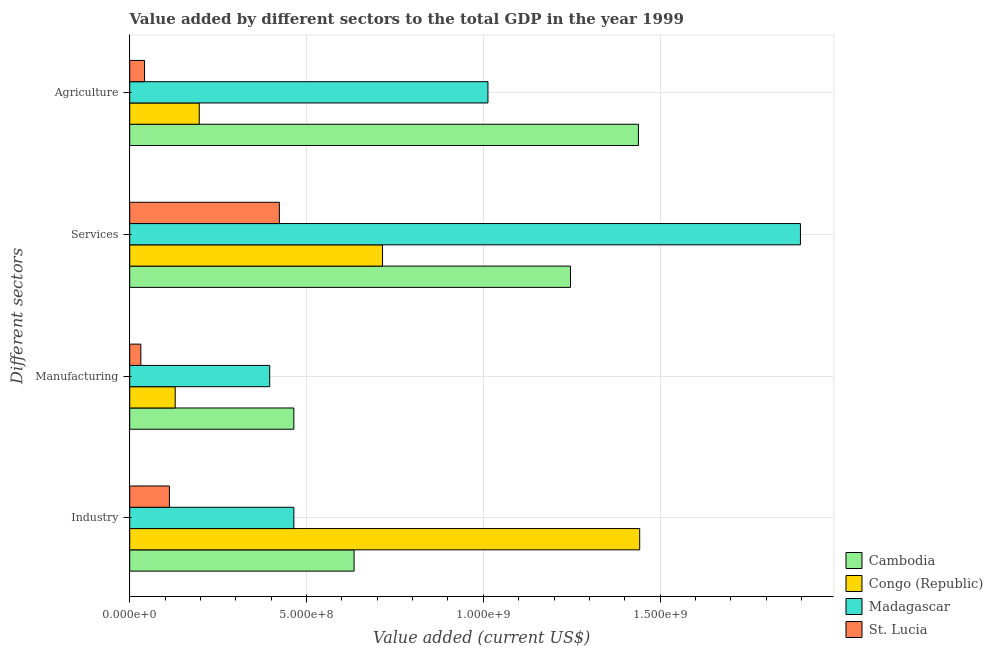How many bars are there on the 1st tick from the top?
Give a very brief answer. 4. How many bars are there on the 3rd tick from the bottom?
Provide a succinct answer. 4. What is the label of the 3rd group of bars from the top?
Provide a short and direct response. Manufacturing. What is the value added by manufacturing sector in Madagascar?
Ensure brevity in your answer.  3.96e+08. Across all countries, what is the maximum value added by industrial sector?
Offer a terse response. 1.44e+09. Across all countries, what is the minimum value added by services sector?
Keep it short and to the point. 4.23e+08. In which country was the value added by services sector maximum?
Provide a short and direct response. Madagascar. In which country was the value added by agricultural sector minimum?
Your answer should be very brief. St. Lucia. What is the total value added by manufacturing sector in the graph?
Provide a succinct answer. 1.02e+09. What is the difference between the value added by agricultural sector in Madagascar and that in St. Lucia?
Offer a terse response. 9.71e+08. What is the difference between the value added by industrial sector in St. Lucia and the value added by agricultural sector in Cambodia?
Your answer should be very brief. -1.33e+09. What is the average value added by services sector per country?
Provide a succinct answer. 1.07e+09. What is the difference between the value added by services sector and value added by manufacturing sector in Madagascar?
Ensure brevity in your answer.  1.50e+09. What is the ratio of the value added by agricultural sector in Cambodia to that in Congo (Republic)?
Offer a terse response. 7.31. Is the value added by services sector in Congo (Republic) less than that in Madagascar?
Your answer should be very brief. Yes. Is the difference between the value added by manufacturing sector in Congo (Republic) and Cambodia greater than the difference between the value added by services sector in Congo (Republic) and Cambodia?
Ensure brevity in your answer.  Yes. What is the difference between the highest and the second highest value added by agricultural sector?
Provide a succinct answer. 4.26e+08. What is the difference between the highest and the lowest value added by manufacturing sector?
Provide a succinct answer. 4.33e+08. In how many countries, is the value added by industrial sector greater than the average value added by industrial sector taken over all countries?
Make the answer very short. 1. What does the 4th bar from the top in Industry represents?
Your answer should be compact. Cambodia. What does the 1st bar from the bottom in Industry represents?
Offer a terse response. Cambodia. How many bars are there?
Your answer should be compact. 16. Are all the bars in the graph horizontal?
Your answer should be compact. Yes. Are the values on the major ticks of X-axis written in scientific E-notation?
Keep it short and to the point. Yes. Does the graph contain grids?
Your answer should be compact. Yes. How many legend labels are there?
Keep it short and to the point. 4. What is the title of the graph?
Make the answer very short. Value added by different sectors to the total GDP in the year 1999. What is the label or title of the X-axis?
Offer a terse response. Value added (current US$). What is the label or title of the Y-axis?
Keep it short and to the point. Different sectors. What is the Value added (current US$) in Cambodia in Industry?
Keep it short and to the point. 6.35e+08. What is the Value added (current US$) of Congo (Republic) in Industry?
Provide a succinct answer. 1.44e+09. What is the Value added (current US$) of Madagascar in Industry?
Ensure brevity in your answer.  4.64e+08. What is the Value added (current US$) in St. Lucia in Industry?
Your response must be concise. 1.12e+08. What is the Value added (current US$) in Cambodia in Manufacturing?
Provide a short and direct response. 4.64e+08. What is the Value added (current US$) in Congo (Republic) in Manufacturing?
Your response must be concise. 1.29e+08. What is the Value added (current US$) in Madagascar in Manufacturing?
Your answer should be very brief. 3.96e+08. What is the Value added (current US$) of St. Lucia in Manufacturing?
Your answer should be compact. 3.14e+07. What is the Value added (current US$) of Cambodia in Services?
Keep it short and to the point. 1.25e+09. What is the Value added (current US$) of Congo (Republic) in Services?
Provide a short and direct response. 7.15e+08. What is the Value added (current US$) of Madagascar in Services?
Offer a terse response. 1.90e+09. What is the Value added (current US$) in St. Lucia in Services?
Give a very brief answer. 4.23e+08. What is the Value added (current US$) of Cambodia in Agriculture?
Offer a very short reply. 1.44e+09. What is the Value added (current US$) of Congo (Republic) in Agriculture?
Your answer should be compact. 1.97e+08. What is the Value added (current US$) of Madagascar in Agriculture?
Offer a terse response. 1.01e+09. What is the Value added (current US$) of St. Lucia in Agriculture?
Your answer should be very brief. 4.19e+07. Across all Different sectors, what is the maximum Value added (current US$) of Cambodia?
Make the answer very short. 1.44e+09. Across all Different sectors, what is the maximum Value added (current US$) of Congo (Republic)?
Offer a very short reply. 1.44e+09. Across all Different sectors, what is the maximum Value added (current US$) of Madagascar?
Offer a very short reply. 1.90e+09. Across all Different sectors, what is the maximum Value added (current US$) of St. Lucia?
Your response must be concise. 4.23e+08. Across all Different sectors, what is the minimum Value added (current US$) of Cambodia?
Provide a succinct answer. 4.64e+08. Across all Different sectors, what is the minimum Value added (current US$) in Congo (Republic)?
Give a very brief answer. 1.29e+08. Across all Different sectors, what is the minimum Value added (current US$) in Madagascar?
Give a very brief answer. 3.96e+08. Across all Different sectors, what is the minimum Value added (current US$) of St. Lucia?
Make the answer very short. 3.14e+07. What is the total Value added (current US$) of Cambodia in the graph?
Your answer should be very brief. 3.78e+09. What is the total Value added (current US$) of Congo (Republic) in the graph?
Provide a succinct answer. 2.48e+09. What is the total Value added (current US$) of Madagascar in the graph?
Your response must be concise. 3.77e+09. What is the total Value added (current US$) in St. Lucia in the graph?
Make the answer very short. 6.09e+08. What is the difference between the Value added (current US$) in Cambodia in Industry and that in Manufacturing?
Offer a very short reply. 1.70e+08. What is the difference between the Value added (current US$) of Congo (Republic) in Industry and that in Manufacturing?
Your response must be concise. 1.31e+09. What is the difference between the Value added (current US$) in Madagascar in Industry and that in Manufacturing?
Ensure brevity in your answer.  6.83e+07. What is the difference between the Value added (current US$) in St. Lucia in Industry and that in Manufacturing?
Offer a very short reply. 8.08e+07. What is the difference between the Value added (current US$) in Cambodia in Industry and that in Services?
Offer a terse response. -6.12e+08. What is the difference between the Value added (current US$) in Congo (Republic) in Industry and that in Services?
Offer a terse response. 7.27e+08. What is the difference between the Value added (current US$) in Madagascar in Industry and that in Services?
Provide a succinct answer. -1.43e+09. What is the difference between the Value added (current US$) in St. Lucia in Industry and that in Services?
Provide a short and direct response. -3.11e+08. What is the difference between the Value added (current US$) in Cambodia in Industry and that in Agriculture?
Provide a short and direct response. -8.04e+08. What is the difference between the Value added (current US$) in Congo (Republic) in Industry and that in Agriculture?
Make the answer very short. 1.25e+09. What is the difference between the Value added (current US$) of Madagascar in Industry and that in Agriculture?
Your answer should be compact. -5.49e+08. What is the difference between the Value added (current US$) in St. Lucia in Industry and that in Agriculture?
Your response must be concise. 7.03e+07. What is the difference between the Value added (current US$) in Cambodia in Manufacturing and that in Services?
Your answer should be compact. -7.82e+08. What is the difference between the Value added (current US$) in Congo (Republic) in Manufacturing and that in Services?
Give a very brief answer. -5.86e+08. What is the difference between the Value added (current US$) in Madagascar in Manufacturing and that in Services?
Make the answer very short. -1.50e+09. What is the difference between the Value added (current US$) of St. Lucia in Manufacturing and that in Services?
Ensure brevity in your answer.  -3.92e+08. What is the difference between the Value added (current US$) of Cambodia in Manufacturing and that in Agriculture?
Provide a succinct answer. -9.75e+08. What is the difference between the Value added (current US$) in Congo (Republic) in Manufacturing and that in Agriculture?
Your answer should be very brief. -6.81e+07. What is the difference between the Value added (current US$) of Madagascar in Manufacturing and that in Agriculture?
Make the answer very short. -6.17e+08. What is the difference between the Value added (current US$) of St. Lucia in Manufacturing and that in Agriculture?
Your answer should be very brief. -1.05e+07. What is the difference between the Value added (current US$) in Cambodia in Services and that in Agriculture?
Your answer should be very brief. -1.92e+08. What is the difference between the Value added (current US$) of Congo (Republic) in Services and that in Agriculture?
Offer a terse response. 5.18e+08. What is the difference between the Value added (current US$) in Madagascar in Services and that in Agriculture?
Offer a very short reply. 8.84e+08. What is the difference between the Value added (current US$) of St. Lucia in Services and that in Agriculture?
Ensure brevity in your answer.  3.81e+08. What is the difference between the Value added (current US$) of Cambodia in Industry and the Value added (current US$) of Congo (Republic) in Manufacturing?
Provide a short and direct response. 5.06e+08. What is the difference between the Value added (current US$) in Cambodia in Industry and the Value added (current US$) in Madagascar in Manufacturing?
Offer a very short reply. 2.39e+08. What is the difference between the Value added (current US$) in Cambodia in Industry and the Value added (current US$) in St. Lucia in Manufacturing?
Ensure brevity in your answer.  6.03e+08. What is the difference between the Value added (current US$) in Congo (Republic) in Industry and the Value added (current US$) in Madagascar in Manufacturing?
Your answer should be compact. 1.05e+09. What is the difference between the Value added (current US$) of Congo (Republic) in Industry and the Value added (current US$) of St. Lucia in Manufacturing?
Your answer should be very brief. 1.41e+09. What is the difference between the Value added (current US$) in Madagascar in Industry and the Value added (current US$) in St. Lucia in Manufacturing?
Your answer should be compact. 4.33e+08. What is the difference between the Value added (current US$) in Cambodia in Industry and the Value added (current US$) in Congo (Republic) in Services?
Your response must be concise. -8.05e+07. What is the difference between the Value added (current US$) in Cambodia in Industry and the Value added (current US$) in Madagascar in Services?
Provide a succinct answer. -1.26e+09. What is the difference between the Value added (current US$) of Cambodia in Industry and the Value added (current US$) of St. Lucia in Services?
Make the answer very short. 2.11e+08. What is the difference between the Value added (current US$) of Congo (Republic) in Industry and the Value added (current US$) of Madagascar in Services?
Ensure brevity in your answer.  -4.55e+08. What is the difference between the Value added (current US$) of Congo (Republic) in Industry and the Value added (current US$) of St. Lucia in Services?
Offer a terse response. 1.02e+09. What is the difference between the Value added (current US$) in Madagascar in Industry and the Value added (current US$) in St. Lucia in Services?
Your answer should be very brief. 4.10e+07. What is the difference between the Value added (current US$) of Cambodia in Industry and the Value added (current US$) of Congo (Republic) in Agriculture?
Your answer should be compact. 4.38e+08. What is the difference between the Value added (current US$) of Cambodia in Industry and the Value added (current US$) of Madagascar in Agriculture?
Give a very brief answer. -3.79e+08. What is the difference between the Value added (current US$) in Cambodia in Industry and the Value added (current US$) in St. Lucia in Agriculture?
Your response must be concise. 5.93e+08. What is the difference between the Value added (current US$) in Congo (Republic) in Industry and the Value added (current US$) in Madagascar in Agriculture?
Keep it short and to the point. 4.29e+08. What is the difference between the Value added (current US$) in Congo (Republic) in Industry and the Value added (current US$) in St. Lucia in Agriculture?
Provide a short and direct response. 1.40e+09. What is the difference between the Value added (current US$) in Madagascar in Industry and the Value added (current US$) in St. Lucia in Agriculture?
Keep it short and to the point. 4.22e+08. What is the difference between the Value added (current US$) in Cambodia in Manufacturing and the Value added (current US$) in Congo (Republic) in Services?
Ensure brevity in your answer.  -2.51e+08. What is the difference between the Value added (current US$) in Cambodia in Manufacturing and the Value added (current US$) in Madagascar in Services?
Your answer should be compact. -1.43e+09. What is the difference between the Value added (current US$) in Cambodia in Manufacturing and the Value added (current US$) in St. Lucia in Services?
Offer a very short reply. 4.10e+07. What is the difference between the Value added (current US$) of Congo (Republic) in Manufacturing and the Value added (current US$) of Madagascar in Services?
Your answer should be very brief. -1.77e+09. What is the difference between the Value added (current US$) in Congo (Republic) in Manufacturing and the Value added (current US$) in St. Lucia in Services?
Provide a short and direct response. -2.95e+08. What is the difference between the Value added (current US$) of Madagascar in Manufacturing and the Value added (current US$) of St. Lucia in Services?
Your answer should be very brief. -2.73e+07. What is the difference between the Value added (current US$) in Cambodia in Manufacturing and the Value added (current US$) in Congo (Republic) in Agriculture?
Make the answer very short. 2.67e+08. What is the difference between the Value added (current US$) in Cambodia in Manufacturing and the Value added (current US$) in Madagascar in Agriculture?
Provide a short and direct response. -5.49e+08. What is the difference between the Value added (current US$) in Cambodia in Manufacturing and the Value added (current US$) in St. Lucia in Agriculture?
Give a very brief answer. 4.22e+08. What is the difference between the Value added (current US$) of Congo (Republic) in Manufacturing and the Value added (current US$) of Madagascar in Agriculture?
Your response must be concise. -8.84e+08. What is the difference between the Value added (current US$) of Congo (Republic) in Manufacturing and the Value added (current US$) of St. Lucia in Agriculture?
Your answer should be compact. 8.67e+07. What is the difference between the Value added (current US$) of Madagascar in Manufacturing and the Value added (current US$) of St. Lucia in Agriculture?
Your response must be concise. 3.54e+08. What is the difference between the Value added (current US$) in Cambodia in Services and the Value added (current US$) in Congo (Republic) in Agriculture?
Your response must be concise. 1.05e+09. What is the difference between the Value added (current US$) of Cambodia in Services and the Value added (current US$) of Madagascar in Agriculture?
Make the answer very short. 2.33e+08. What is the difference between the Value added (current US$) in Cambodia in Services and the Value added (current US$) in St. Lucia in Agriculture?
Your answer should be very brief. 1.20e+09. What is the difference between the Value added (current US$) in Congo (Republic) in Services and the Value added (current US$) in Madagascar in Agriculture?
Your response must be concise. -2.98e+08. What is the difference between the Value added (current US$) of Congo (Republic) in Services and the Value added (current US$) of St. Lucia in Agriculture?
Offer a very short reply. 6.73e+08. What is the difference between the Value added (current US$) in Madagascar in Services and the Value added (current US$) in St. Lucia in Agriculture?
Provide a succinct answer. 1.85e+09. What is the average Value added (current US$) of Cambodia per Different sectors?
Offer a very short reply. 9.46e+08. What is the average Value added (current US$) of Congo (Republic) per Different sectors?
Offer a terse response. 6.21e+08. What is the average Value added (current US$) of Madagascar per Different sectors?
Give a very brief answer. 9.43e+08. What is the average Value added (current US$) in St. Lucia per Different sectors?
Provide a succinct answer. 1.52e+08. What is the difference between the Value added (current US$) of Cambodia and Value added (current US$) of Congo (Republic) in Industry?
Your answer should be very brief. -8.08e+08. What is the difference between the Value added (current US$) in Cambodia and Value added (current US$) in Madagascar in Industry?
Make the answer very short. 1.70e+08. What is the difference between the Value added (current US$) in Cambodia and Value added (current US$) in St. Lucia in Industry?
Offer a very short reply. 5.22e+08. What is the difference between the Value added (current US$) of Congo (Republic) and Value added (current US$) of Madagascar in Industry?
Make the answer very short. 9.78e+08. What is the difference between the Value added (current US$) of Congo (Republic) and Value added (current US$) of St. Lucia in Industry?
Ensure brevity in your answer.  1.33e+09. What is the difference between the Value added (current US$) of Madagascar and Value added (current US$) of St. Lucia in Industry?
Your answer should be compact. 3.52e+08. What is the difference between the Value added (current US$) of Cambodia and Value added (current US$) of Congo (Republic) in Manufacturing?
Provide a short and direct response. 3.36e+08. What is the difference between the Value added (current US$) in Cambodia and Value added (current US$) in Madagascar in Manufacturing?
Offer a terse response. 6.83e+07. What is the difference between the Value added (current US$) of Cambodia and Value added (current US$) of St. Lucia in Manufacturing?
Offer a very short reply. 4.33e+08. What is the difference between the Value added (current US$) in Congo (Republic) and Value added (current US$) in Madagascar in Manufacturing?
Give a very brief answer. -2.67e+08. What is the difference between the Value added (current US$) of Congo (Republic) and Value added (current US$) of St. Lucia in Manufacturing?
Your response must be concise. 9.72e+07. What is the difference between the Value added (current US$) of Madagascar and Value added (current US$) of St. Lucia in Manufacturing?
Give a very brief answer. 3.64e+08. What is the difference between the Value added (current US$) in Cambodia and Value added (current US$) in Congo (Republic) in Services?
Your answer should be very brief. 5.32e+08. What is the difference between the Value added (current US$) in Cambodia and Value added (current US$) in Madagascar in Services?
Keep it short and to the point. -6.50e+08. What is the difference between the Value added (current US$) in Cambodia and Value added (current US$) in St. Lucia in Services?
Ensure brevity in your answer.  8.23e+08. What is the difference between the Value added (current US$) in Congo (Republic) and Value added (current US$) in Madagascar in Services?
Your answer should be compact. -1.18e+09. What is the difference between the Value added (current US$) in Congo (Republic) and Value added (current US$) in St. Lucia in Services?
Keep it short and to the point. 2.92e+08. What is the difference between the Value added (current US$) of Madagascar and Value added (current US$) of St. Lucia in Services?
Provide a succinct answer. 1.47e+09. What is the difference between the Value added (current US$) of Cambodia and Value added (current US$) of Congo (Republic) in Agriculture?
Ensure brevity in your answer.  1.24e+09. What is the difference between the Value added (current US$) in Cambodia and Value added (current US$) in Madagascar in Agriculture?
Provide a succinct answer. 4.26e+08. What is the difference between the Value added (current US$) of Cambodia and Value added (current US$) of St. Lucia in Agriculture?
Ensure brevity in your answer.  1.40e+09. What is the difference between the Value added (current US$) in Congo (Republic) and Value added (current US$) in Madagascar in Agriculture?
Give a very brief answer. -8.16e+08. What is the difference between the Value added (current US$) of Congo (Republic) and Value added (current US$) of St. Lucia in Agriculture?
Provide a succinct answer. 1.55e+08. What is the difference between the Value added (current US$) of Madagascar and Value added (current US$) of St. Lucia in Agriculture?
Keep it short and to the point. 9.71e+08. What is the ratio of the Value added (current US$) in Cambodia in Industry to that in Manufacturing?
Offer a terse response. 1.37. What is the ratio of the Value added (current US$) of Congo (Republic) in Industry to that in Manufacturing?
Your answer should be very brief. 11.21. What is the ratio of the Value added (current US$) of Madagascar in Industry to that in Manufacturing?
Provide a succinct answer. 1.17. What is the ratio of the Value added (current US$) in St. Lucia in Industry to that in Manufacturing?
Offer a very short reply. 3.57. What is the ratio of the Value added (current US$) of Cambodia in Industry to that in Services?
Ensure brevity in your answer.  0.51. What is the ratio of the Value added (current US$) of Congo (Republic) in Industry to that in Services?
Ensure brevity in your answer.  2.02. What is the ratio of the Value added (current US$) in Madagascar in Industry to that in Services?
Ensure brevity in your answer.  0.24. What is the ratio of the Value added (current US$) in St. Lucia in Industry to that in Services?
Your response must be concise. 0.27. What is the ratio of the Value added (current US$) in Cambodia in Industry to that in Agriculture?
Provide a succinct answer. 0.44. What is the ratio of the Value added (current US$) in Congo (Republic) in Industry to that in Agriculture?
Make the answer very short. 7.33. What is the ratio of the Value added (current US$) in Madagascar in Industry to that in Agriculture?
Offer a terse response. 0.46. What is the ratio of the Value added (current US$) in St. Lucia in Industry to that in Agriculture?
Make the answer very short. 2.68. What is the ratio of the Value added (current US$) in Cambodia in Manufacturing to that in Services?
Provide a short and direct response. 0.37. What is the ratio of the Value added (current US$) of Congo (Republic) in Manufacturing to that in Services?
Give a very brief answer. 0.18. What is the ratio of the Value added (current US$) in Madagascar in Manufacturing to that in Services?
Your answer should be compact. 0.21. What is the ratio of the Value added (current US$) of St. Lucia in Manufacturing to that in Services?
Your answer should be very brief. 0.07. What is the ratio of the Value added (current US$) in Cambodia in Manufacturing to that in Agriculture?
Your answer should be very brief. 0.32. What is the ratio of the Value added (current US$) in Congo (Republic) in Manufacturing to that in Agriculture?
Your answer should be compact. 0.65. What is the ratio of the Value added (current US$) in Madagascar in Manufacturing to that in Agriculture?
Make the answer very short. 0.39. What is the ratio of the Value added (current US$) of St. Lucia in Manufacturing to that in Agriculture?
Ensure brevity in your answer.  0.75. What is the ratio of the Value added (current US$) in Cambodia in Services to that in Agriculture?
Keep it short and to the point. 0.87. What is the ratio of the Value added (current US$) of Congo (Republic) in Services to that in Agriculture?
Your answer should be compact. 3.63. What is the ratio of the Value added (current US$) of Madagascar in Services to that in Agriculture?
Your answer should be very brief. 1.87. What is the ratio of the Value added (current US$) of St. Lucia in Services to that in Agriculture?
Offer a very short reply. 10.09. What is the difference between the highest and the second highest Value added (current US$) in Cambodia?
Offer a very short reply. 1.92e+08. What is the difference between the highest and the second highest Value added (current US$) of Congo (Republic)?
Your answer should be compact. 7.27e+08. What is the difference between the highest and the second highest Value added (current US$) in Madagascar?
Your answer should be compact. 8.84e+08. What is the difference between the highest and the second highest Value added (current US$) in St. Lucia?
Give a very brief answer. 3.11e+08. What is the difference between the highest and the lowest Value added (current US$) of Cambodia?
Your answer should be compact. 9.75e+08. What is the difference between the highest and the lowest Value added (current US$) of Congo (Republic)?
Your answer should be compact. 1.31e+09. What is the difference between the highest and the lowest Value added (current US$) in Madagascar?
Give a very brief answer. 1.50e+09. What is the difference between the highest and the lowest Value added (current US$) of St. Lucia?
Give a very brief answer. 3.92e+08. 